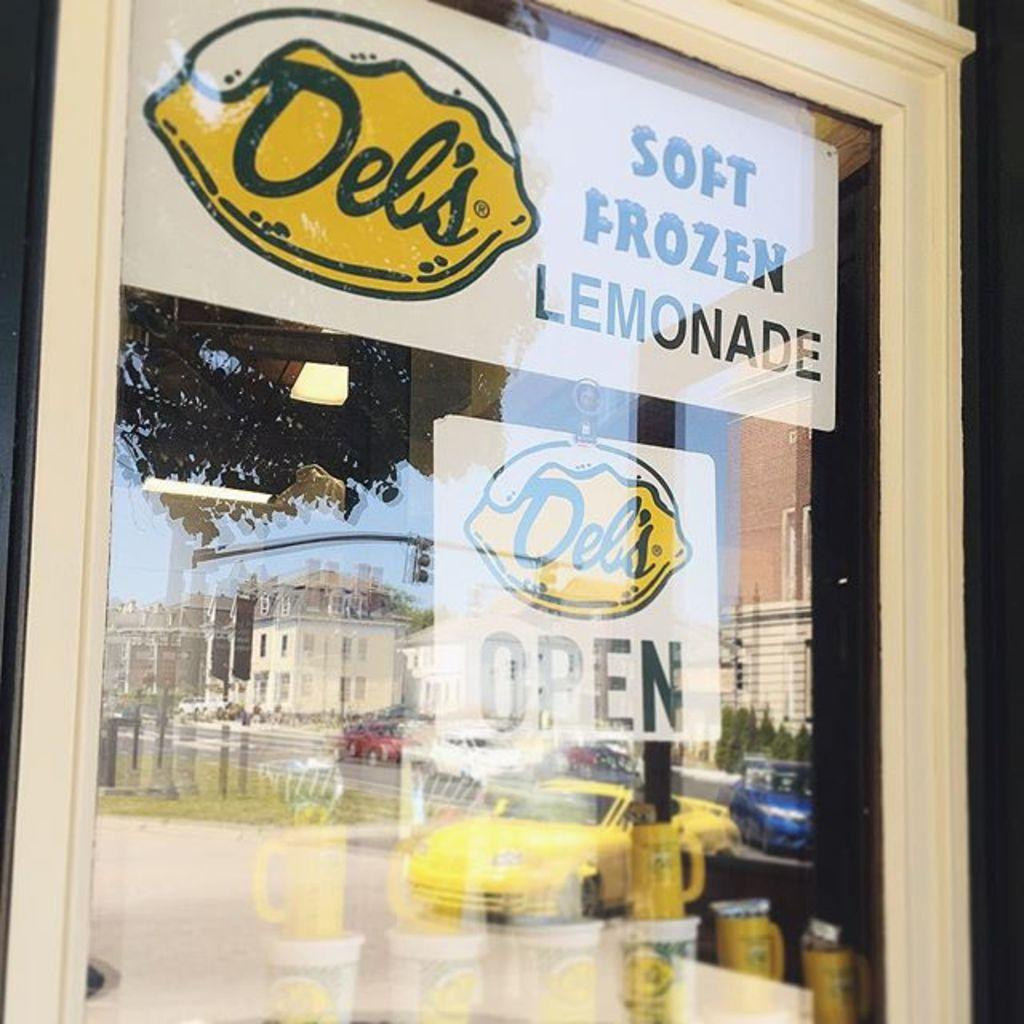<image>
Offer a succinct explanation of the picture presented. The Del's frozen lemonade store is open on this sunny day. 